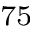<formula> <loc_0><loc_0><loc_500><loc_500>^ { 7 5 }</formula> 